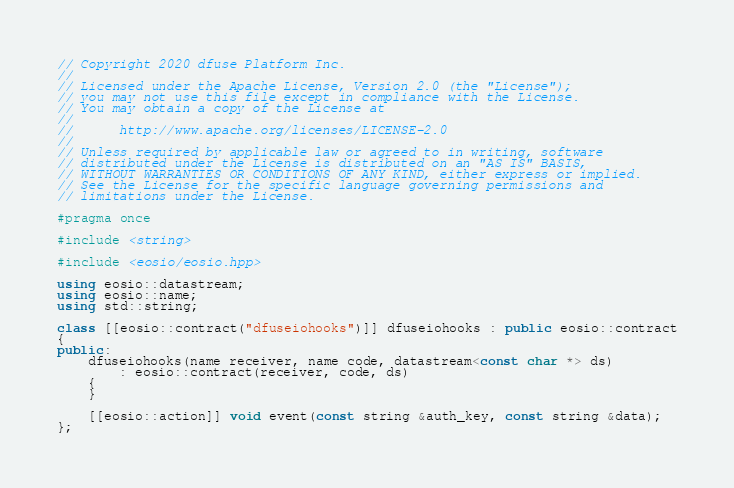Convert code to text. <code><loc_0><loc_0><loc_500><loc_500><_C++_>// Copyright 2020 dfuse Platform Inc.
//
// Licensed under the Apache License, Version 2.0 (the "License");
// you may not use this file except in compliance with the License.
// You may obtain a copy of the License at
//
//      http://www.apache.org/licenses/LICENSE-2.0
//
// Unless required by applicable law or agreed to in writing, software
// distributed under the License is distributed on an "AS IS" BASIS,
// WITHOUT WARRANTIES OR CONDITIONS OF ANY KIND, either express or implied.
// See the License for the specific language governing permissions and
// limitations under the License.

#pragma once

#include <string>

#include <eosio/eosio.hpp>

using eosio::datastream;
using eosio::name;
using std::string;

class [[eosio::contract("dfuseiohooks")]] dfuseiohooks : public eosio::contract
{
public:
    dfuseiohooks(name receiver, name code, datastream<const char *> ds)
        : eosio::contract(receiver, code, ds)
    {
    }

    [[eosio::action]] void event(const string &auth_key, const string &data);
};
</code> 